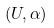Convert formula to latex. <formula><loc_0><loc_0><loc_500><loc_500>( U , \alpha )</formula> 